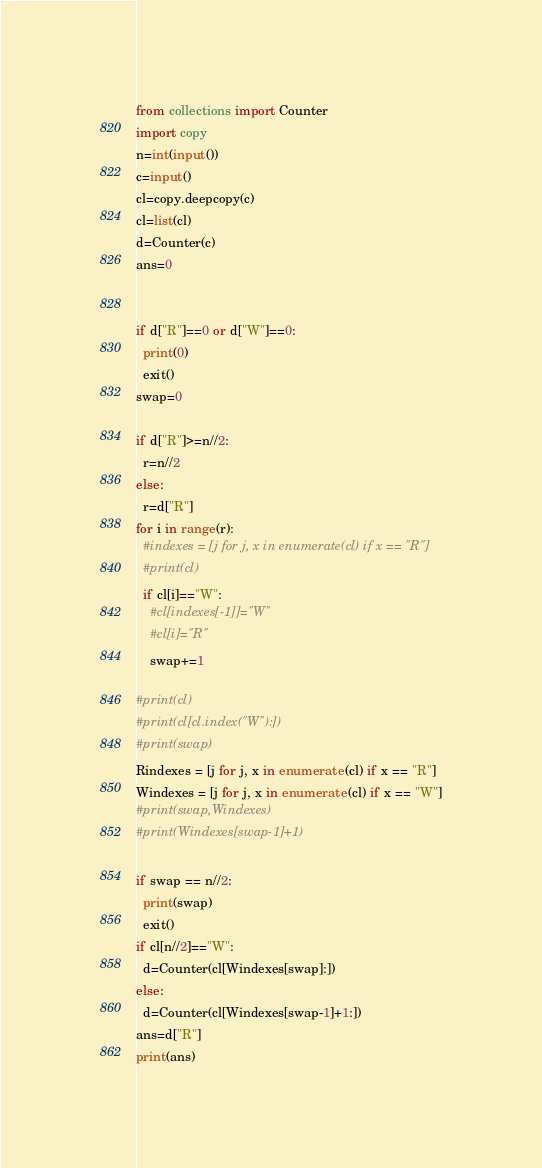<code> <loc_0><loc_0><loc_500><loc_500><_Python_>from collections import Counter
import copy 
n=int(input())
c=input()
cl=copy.deepcopy(c)
cl=list(cl)
d=Counter(c)
ans=0


if d["R"]==0 or d["W"]==0:
  print(0)
  exit()
swap=0

if d["R"]>=n//2:
  r=n//2
else:
  r=d["R"]
for i in range(r):
  #indexes = [j for j, x in enumerate(cl) if x == "R"]
  #print(cl)
  if cl[i]=="W":
    #cl[indexes[-1]]="W"
    #cl[i]="R"
    swap+=1

#print(cl)
#print(cl[cl.index("W"):])
#print(swap)
Rindexes = [j for j, x in enumerate(cl) if x == "R"]
Windexes = [j for j, x in enumerate(cl) if x == "W"]
#print(swap,Windexes)
#print(Windexes[swap-1]+1)

if swap == n//2:
  print(swap)
  exit()
if cl[n//2]=="W":
  d=Counter(cl[Windexes[swap]:])
else:
  d=Counter(cl[Windexes[swap-1]+1:])
ans=d["R"]
print(ans)</code> 